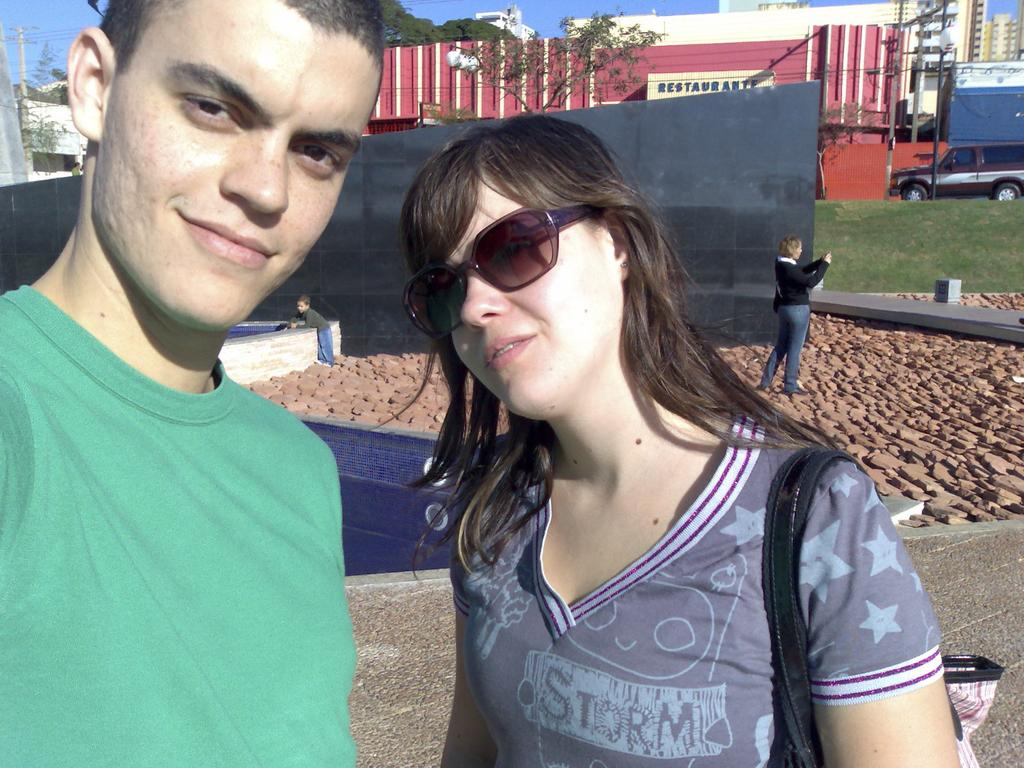How many people are in the image? There are two persons standing in the center of the image. What can be seen in the background of the image? There is a building in the background of the image. What type of ground is visible at the bottom of the image? There is grass at the bottom of the image. What else is visible in the image besides the people and the building? There is a road visible in the image. What type of ball is being used by the person on the left in the image? There is no ball present in the image; only the two persons, the building, grass, and the road are visible. 